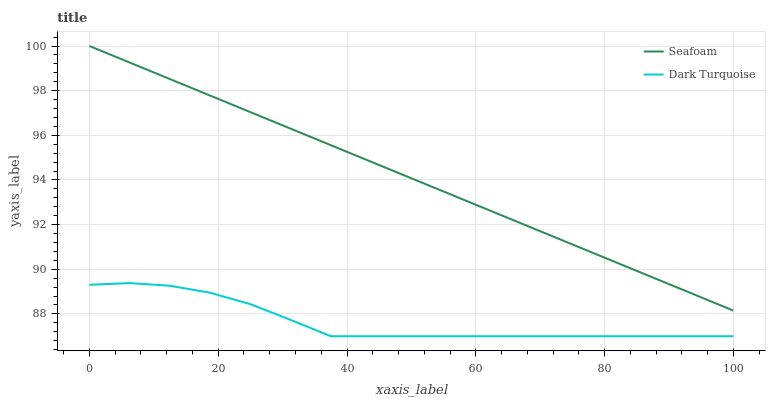Does Seafoam have the minimum area under the curve?
Answer yes or no. No. Is Seafoam the roughest?
Answer yes or no. No. Does Seafoam have the lowest value?
Answer yes or no. No. Is Dark Turquoise less than Seafoam?
Answer yes or no. Yes. Is Seafoam greater than Dark Turquoise?
Answer yes or no. Yes. Does Dark Turquoise intersect Seafoam?
Answer yes or no. No. 